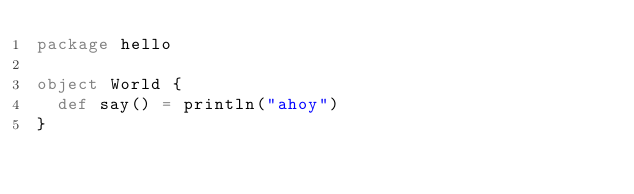Convert code to text. <code><loc_0><loc_0><loc_500><loc_500><_Scala_>package hello

object World {
  def say() = println("ahoy")
}</code> 